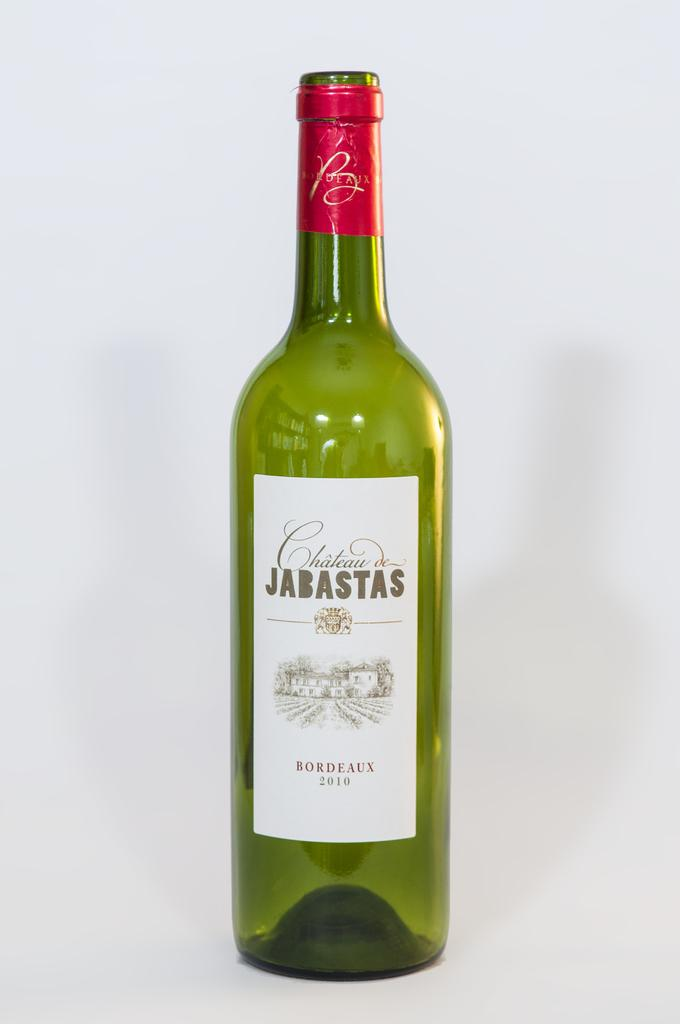What is the main object in the foreground of the image? There is a green colored bottle in the foreground of the image. What color is the background of the image? The background of the image is in white color. How many seeds can be seen on the brick in the image? There is no brick or seeds present in the image; it only features a green colored bottle in the foreground and a white background. 